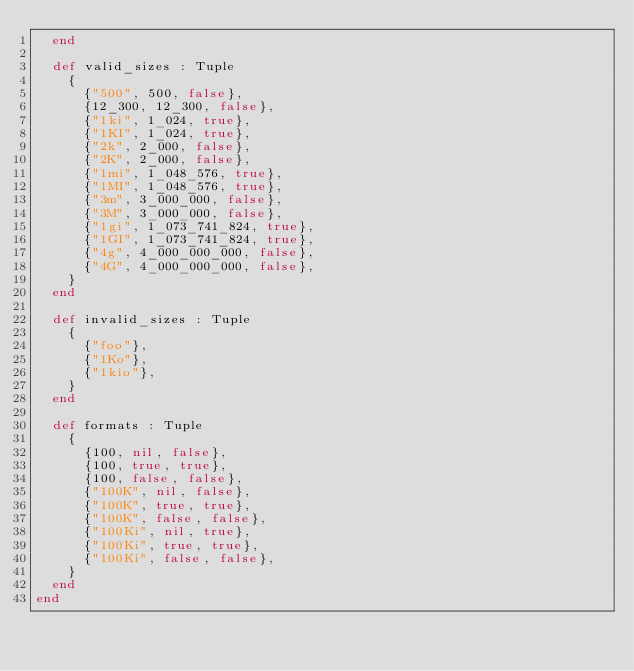Convert code to text. <code><loc_0><loc_0><loc_500><loc_500><_Crystal_>  end

  def valid_sizes : Tuple
    {
      {"500", 500, false},
      {12_300, 12_300, false},
      {"1ki", 1_024, true},
      {"1KI", 1_024, true},
      {"2k", 2_000, false},
      {"2K", 2_000, false},
      {"1mi", 1_048_576, true},
      {"1MI", 1_048_576, true},
      {"3m", 3_000_000, false},
      {"3M", 3_000_000, false},
      {"1gi", 1_073_741_824, true},
      {"1GI", 1_073_741_824, true},
      {"4g", 4_000_000_000, false},
      {"4G", 4_000_000_000, false},
    }
  end

  def invalid_sizes : Tuple
    {
      {"foo"},
      {"1Ko"},
      {"1kio"},
    }
  end

  def formats : Tuple
    {
      {100, nil, false},
      {100, true, true},
      {100, false, false},
      {"100K", nil, false},
      {"100K", true, true},
      {"100K", false, false},
      {"100Ki", nil, true},
      {"100Ki", true, true},
      {"100Ki", false, false},
    }
  end
end
</code> 